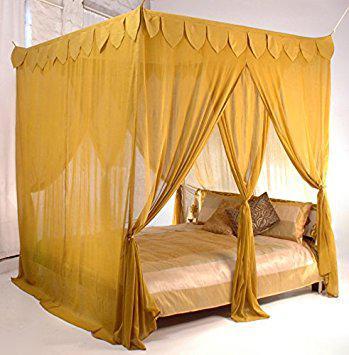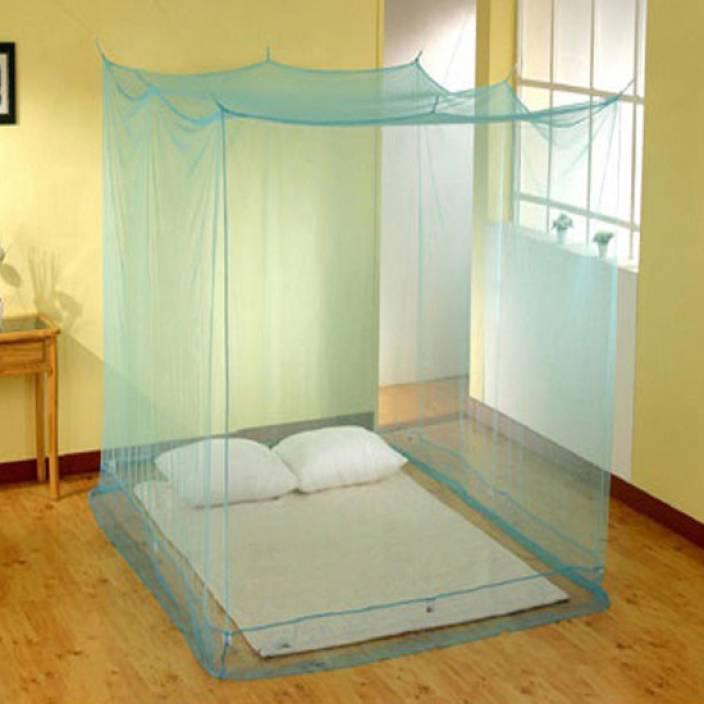The first image is the image on the left, the second image is the image on the right. For the images shown, is this caption "None of the nets above the bed are pink or yellow." true? Answer yes or no. No. The first image is the image on the left, the second image is the image on the right. Examine the images to the left and right. Is the description "There is a nightstand next to a rounded mosquito net or canopy that covers the bed." accurate? Answer yes or no. No. 